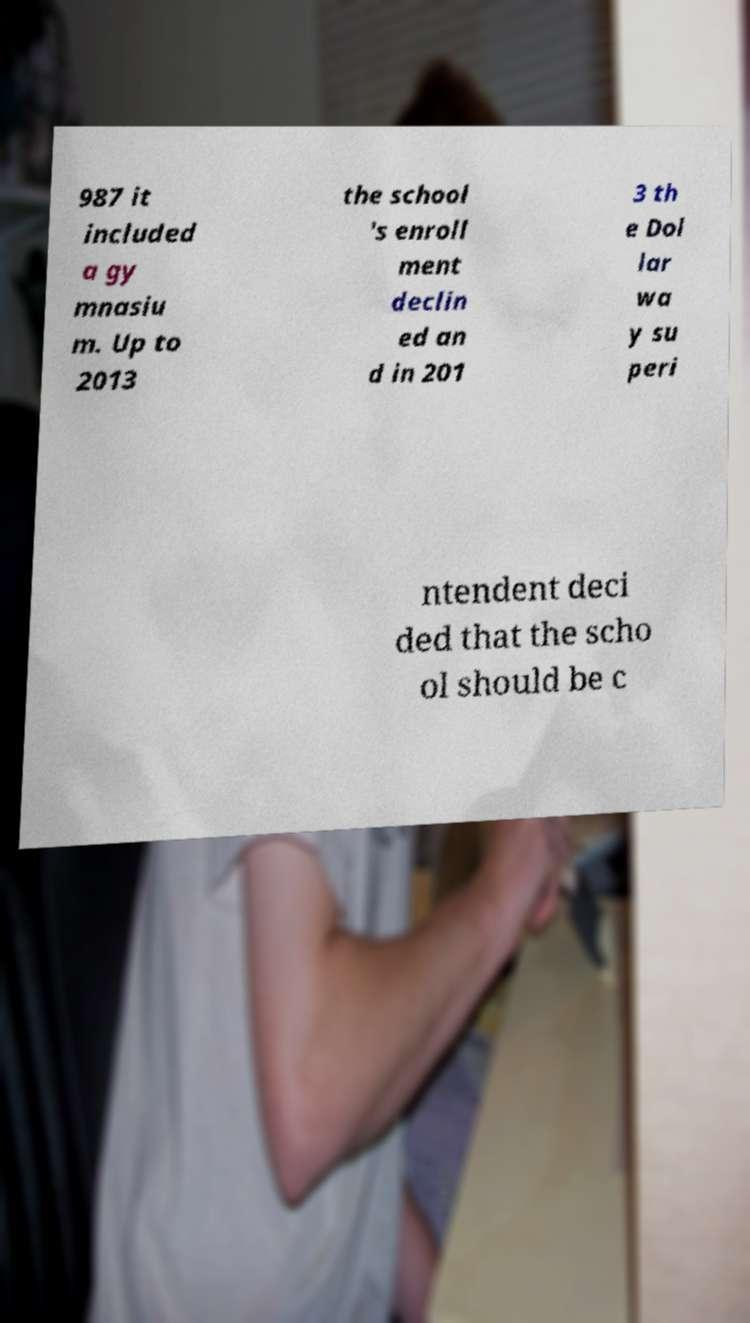What messages or text are displayed in this image? I need them in a readable, typed format. 987 it included a gy mnasiu m. Up to 2013 the school 's enroll ment declin ed an d in 201 3 th e Dol lar wa y su peri ntendent deci ded that the scho ol should be c 